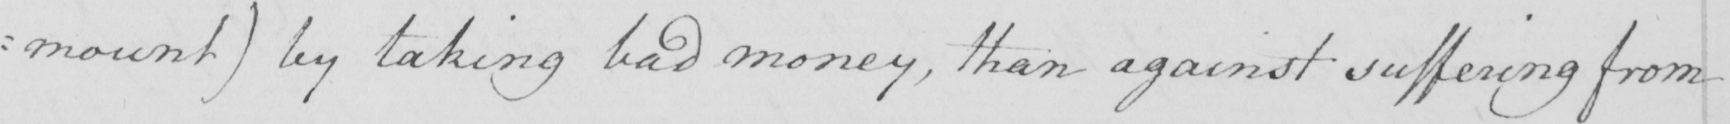Transcribe the text shown in this historical manuscript line. : mount )  by taking bad money , than against suffering from 